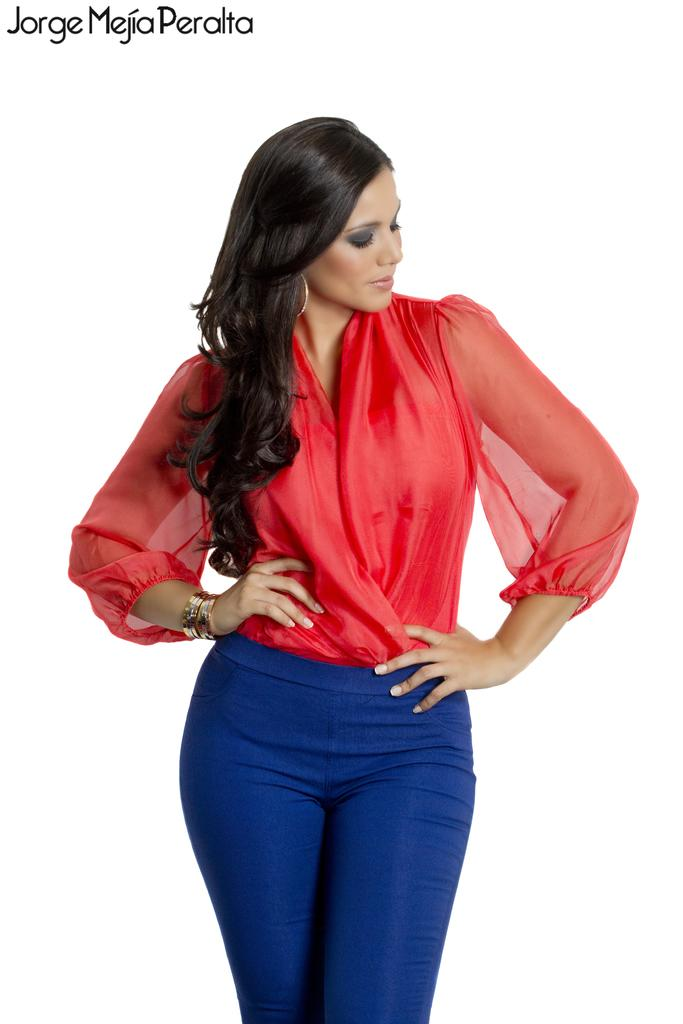What is the main subject of the image? The main subject of the image is a woman standing. Can you describe any text present in the image? Yes, there is some text at the top left side of the image. What type of oatmeal is the woman eating in the image? There is no oatmeal present in the image, and the woman is not eating anything. What idea does the text at the top left side of the image convey? The text cannot be read or interpreted in the image, so it is not possible to determine what idea it conveys. 